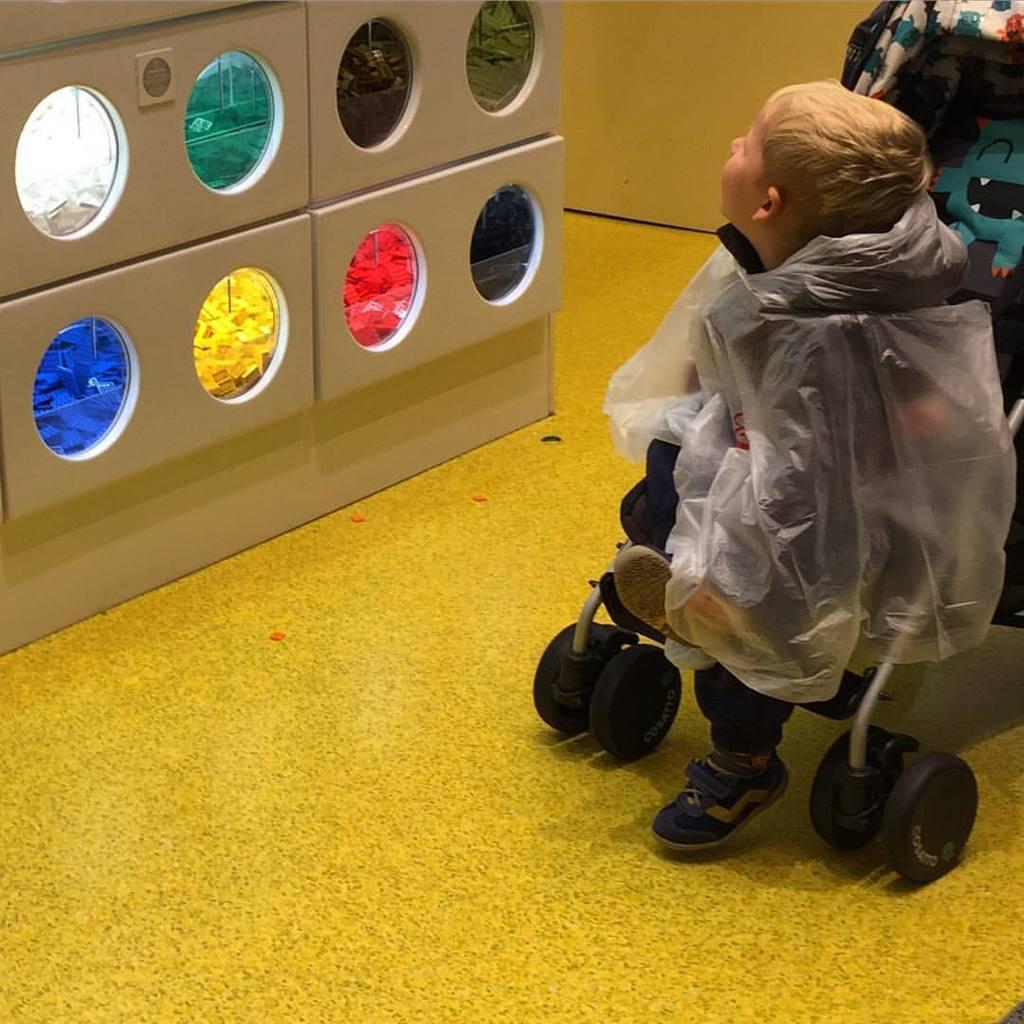Could you give a brief overview of what you see in this image? On the right side of the image there is a baby sitting on the stroller. And on the left side of the image there is a machine with different colors round shapes. 